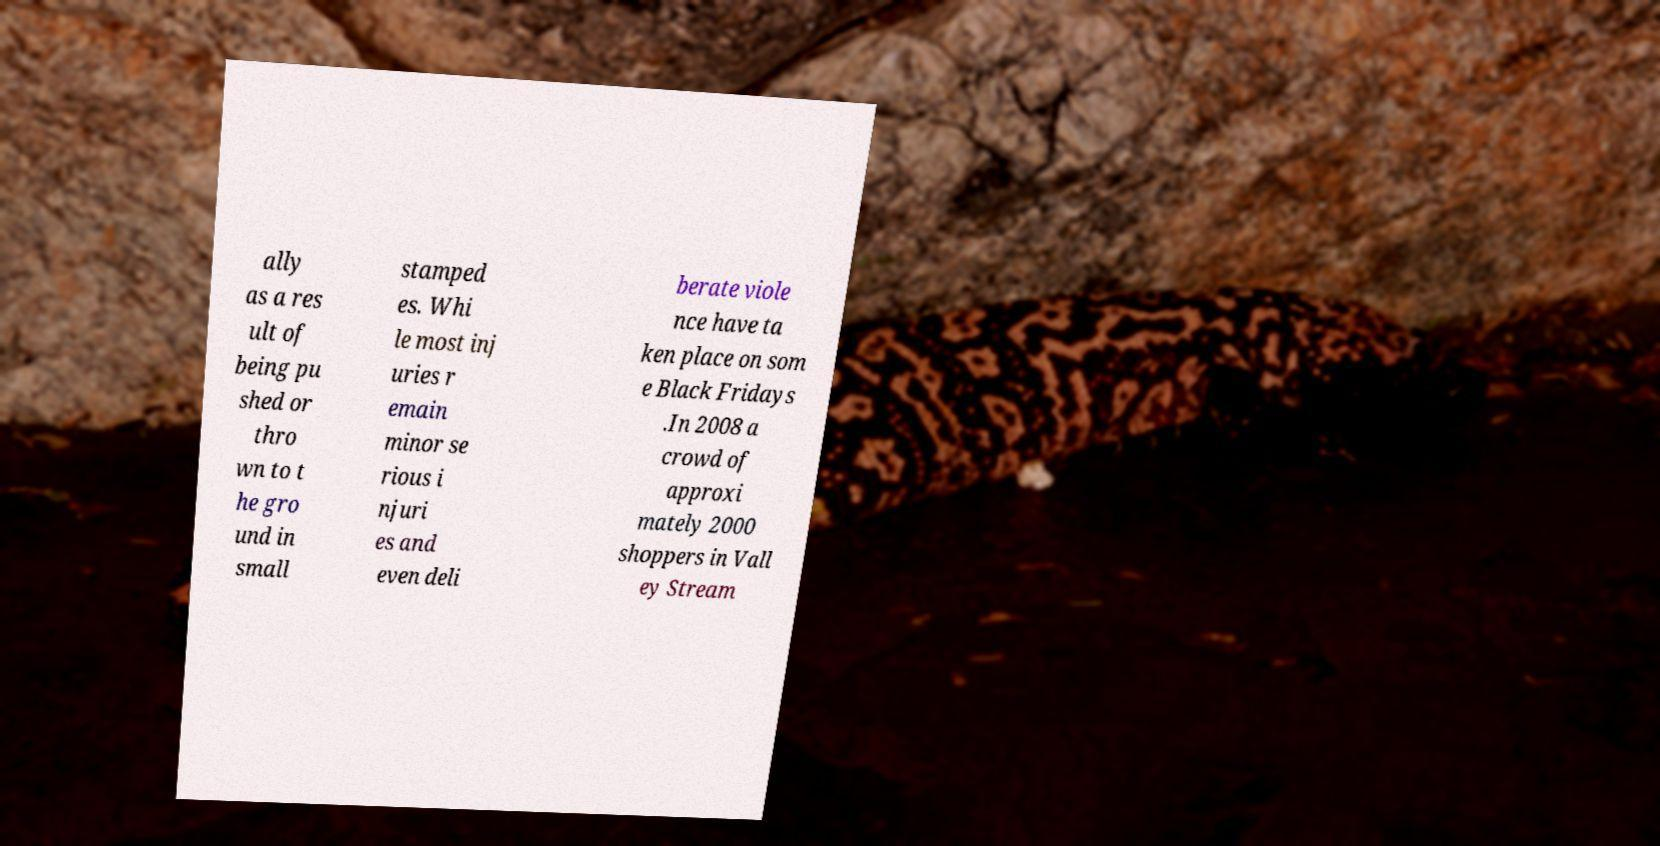I need the written content from this picture converted into text. Can you do that? ally as a res ult of being pu shed or thro wn to t he gro und in small stamped es. Whi le most inj uries r emain minor se rious i njuri es and even deli berate viole nce have ta ken place on som e Black Fridays .In 2008 a crowd of approxi mately 2000 shoppers in Vall ey Stream 